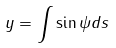<formula> <loc_0><loc_0><loc_500><loc_500>y = \int \sin \psi d s</formula> 